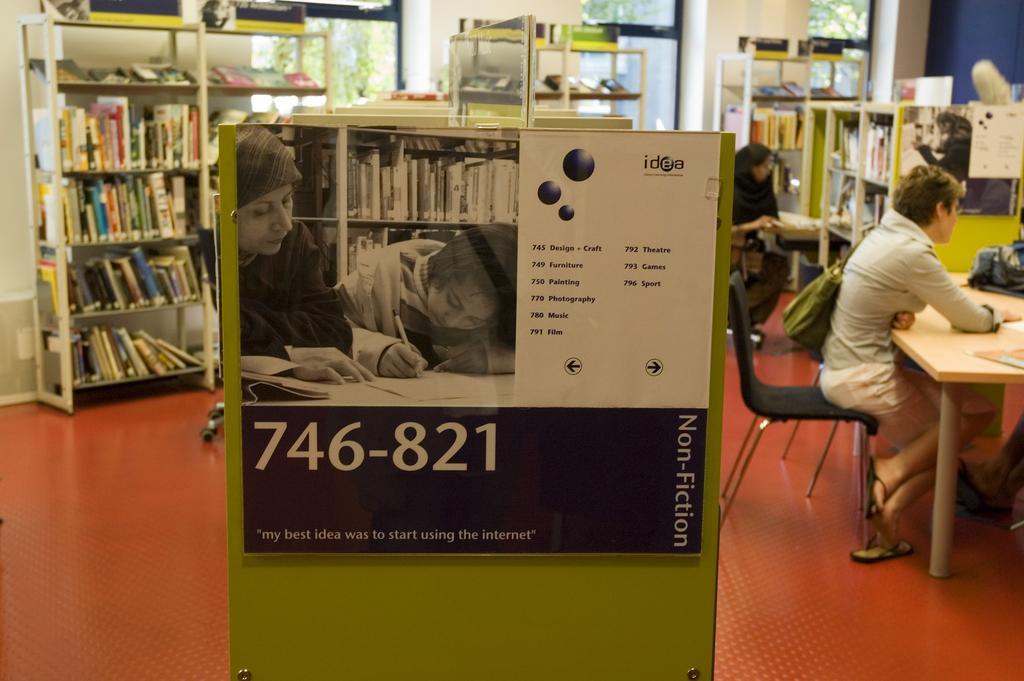Can you describe this image briefly? There is a poster attached to the board in this picture. In the background, there are some people sitting in the chairs in front of a table. We can observe some bookshelves in which books were placed here. There are some Windows in the room. 